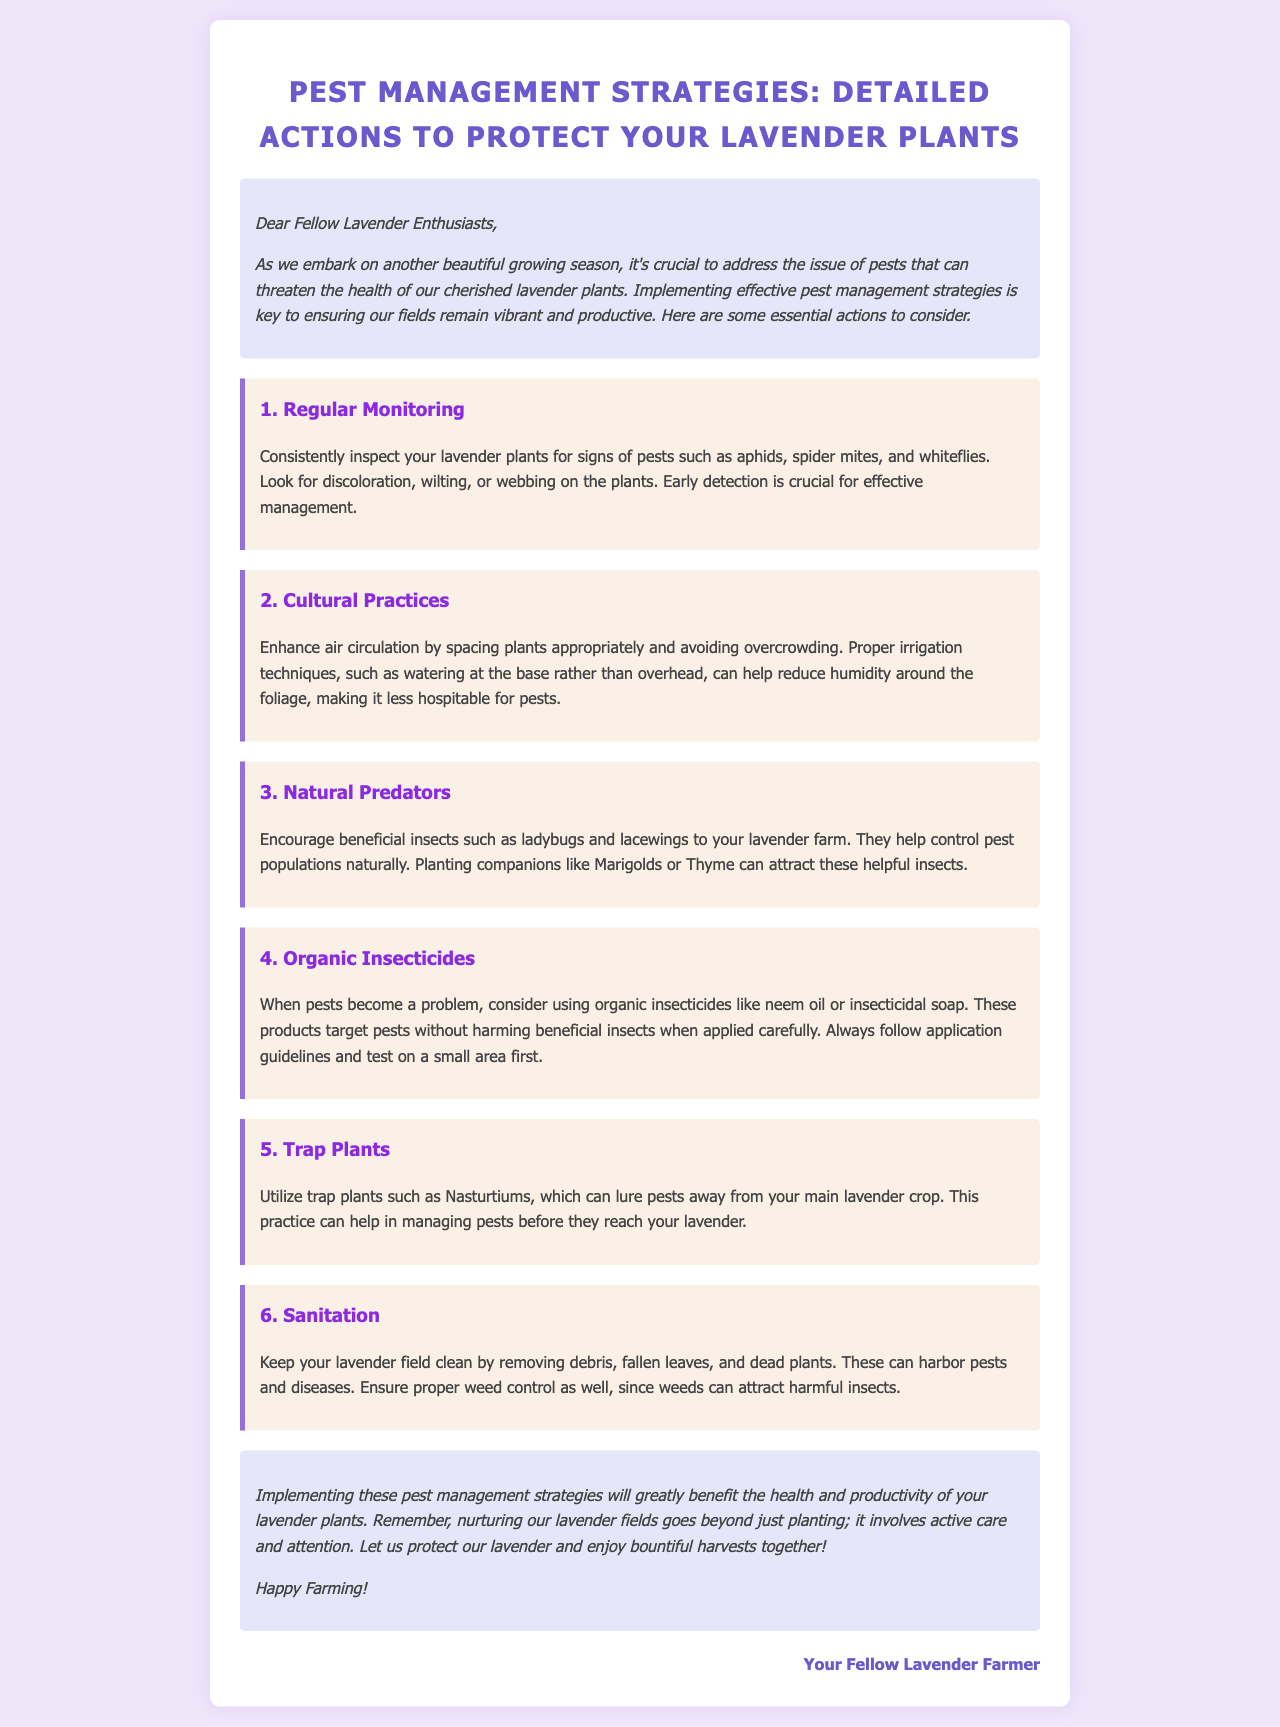What are the main pests mentioned? The document lists aphids, spider mites, and whiteflies as the main pests.
Answer: aphids, spider mites, whiteflies What is a beneficial insect to encourage? The document suggests encouraging ladybugs and lacewings to control pest populations.
Answer: ladybugs, lacewings What irrigation technique is recommended? The document recommends watering at the base rather than overhead to reduce humidity.
Answer: at the base How many pest management strategies are listed? The document enumerates six strategies for pest management.
Answer: six What is the purpose of trap plants? Trap plants are used to lure pests away from the main lavender crop.
Answer: to lure pests What should be removed for sanitation? The document advises removing debris, fallen leaves, and dead plants to keep the field clean.
Answer: debris, fallen leaves, dead plants What type of insecticides should be used when pests become a problem? The document recommends using organic insecticides like neem oil or insecticidal soap.
Answer: organic insecticides What is an action to enhance air circulation? The document suggests spacing plants appropriately and avoiding overcrowding.
Answer: spacing plants What companion plants attract beneficial insects? The document mentions Marigolds or Thyme as companion plants to attract beneficial insects.
Answer: Marigolds, Thyme 